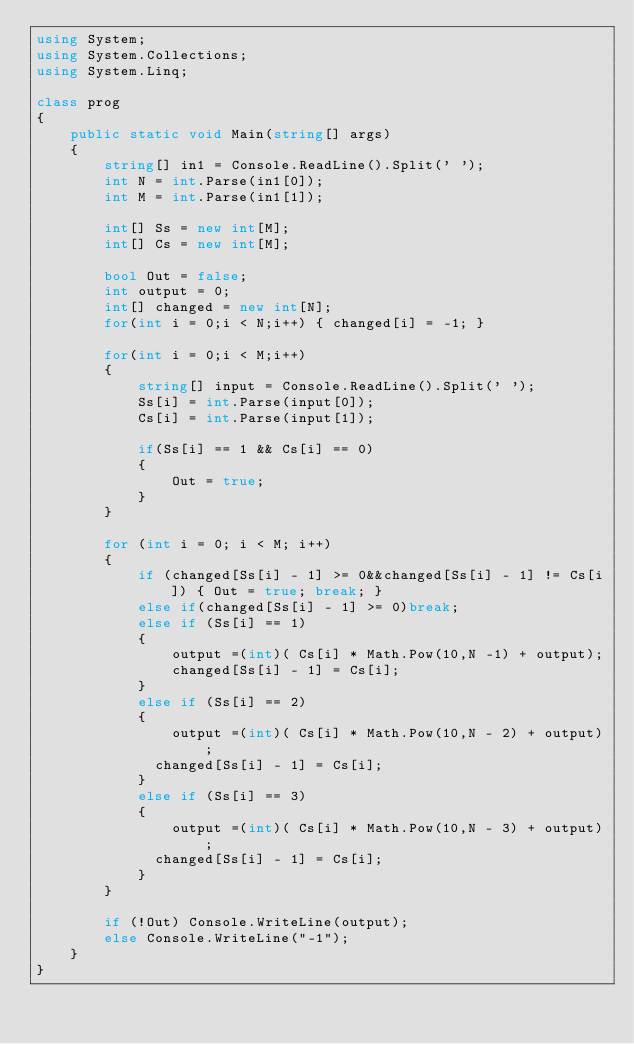<code> <loc_0><loc_0><loc_500><loc_500><_C#_>using System;
using System.Collections;
using System.Linq;

class prog
{
    public static void Main(string[] args)
    {
        string[] in1 = Console.ReadLine().Split(' ');
        int N = int.Parse(in1[0]);
        int M = int.Parse(in1[1]);

        int[] Ss = new int[M];
        int[] Cs = new int[M];

        bool Out = false;
        int output = 0;
        int[] changed = new int[N];
        for(int i = 0;i < N;i++) { changed[i] = -1; }

        for(int i = 0;i < M;i++)
        {
            string[] input = Console.ReadLine().Split(' ');
            Ss[i] = int.Parse(input[0]);
            Cs[i] = int.Parse(input[1]);

            if(Ss[i] == 1 && Cs[i] == 0)
            {
                Out = true;
            }
        }

        for (int i = 0; i < M; i++)
        {
            if (changed[Ss[i] - 1] >= 0&&changed[Ss[i] - 1] != Cs[i]) { Out = true; break; }
          	else if(changed[Ss[i] - 1] >= 0)break;
            else if (Ss[i] == 1)
            {
                output =(int)( Cs[i] * Math.Pow(10,N -1) + output);
              	changed[Ss[i] - 1] = Cs[i];
            }
            else if (Ss[i] == 2)
            {
                output =(int)( Cs[i] * Math.Pow(10,N - 2) + output);
              changed[Ss[i] - 1] = Cs[i];
            }
            else if (Ss[i] == 3)
            {
                output =(int)( Cs[i] * Math.Pow(10,N - 3) + output);
              changed[Ss[i] - 1] = Cs[i];
            }
        }

        if (!Out) Console.WriteLine(output);
        else Console.WriteLine("-1");
    }
}</code> 